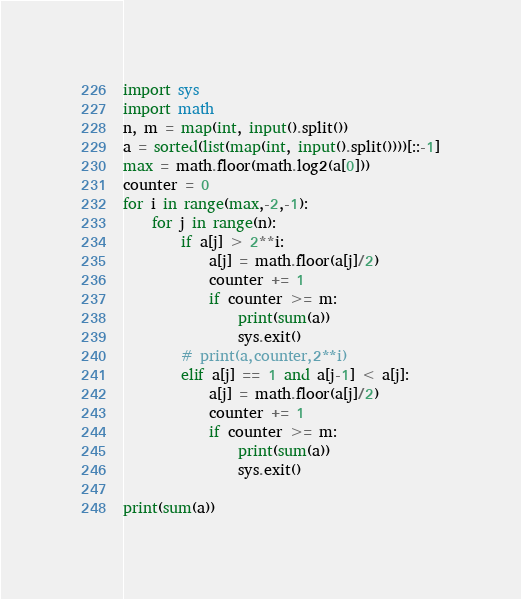Convert code to text. <code><loc_0><loc_0><loc_500><loc_500><_Python_>import sys
import math
n, m = map(int, input().split())
a = sorted(list(map(int, input().split())))[::-1]
max = math.floor(math.log2(a[0]))
counter = 0
for i in range(max,-2,-1):
    for j in range(n):
        if a[j] > 2**i:
            a[j] = math.floor(a[j]/2)
            counter += 1
            if counter >= m:
                print(sum(a))
                sys.exit()
        # print(a,counter,2**i)
        elif a[j] == 1 and a[j-1] < a[j]:
            a[j] = math.floor(a[j]/2)
            counter += 1
            if counter >= m:
                print(sum(a))
                sys.exit()

print(sum(a))
</code> 